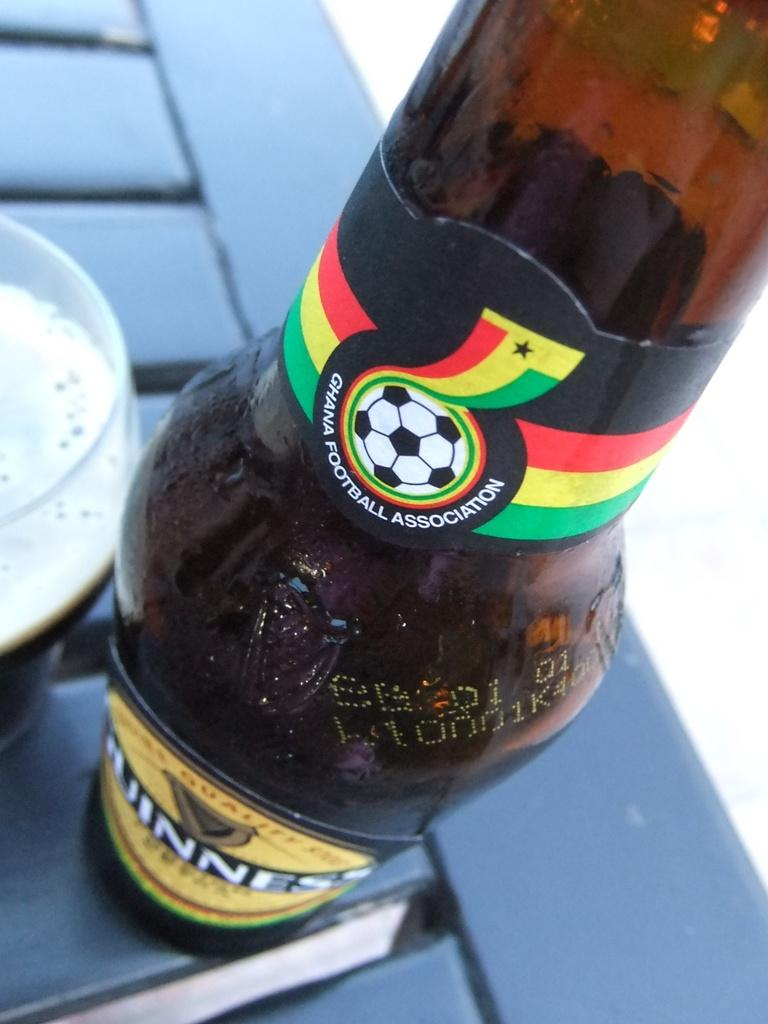What is present on the table in the image? There is a bottle and a glass on the table in the image. Can you describe the objects on the table? The objects on the table are a bottle and a glass. What type of bells can be heard ringing in the image? There are no bells present in the image, and therefore no sound can be heard. 